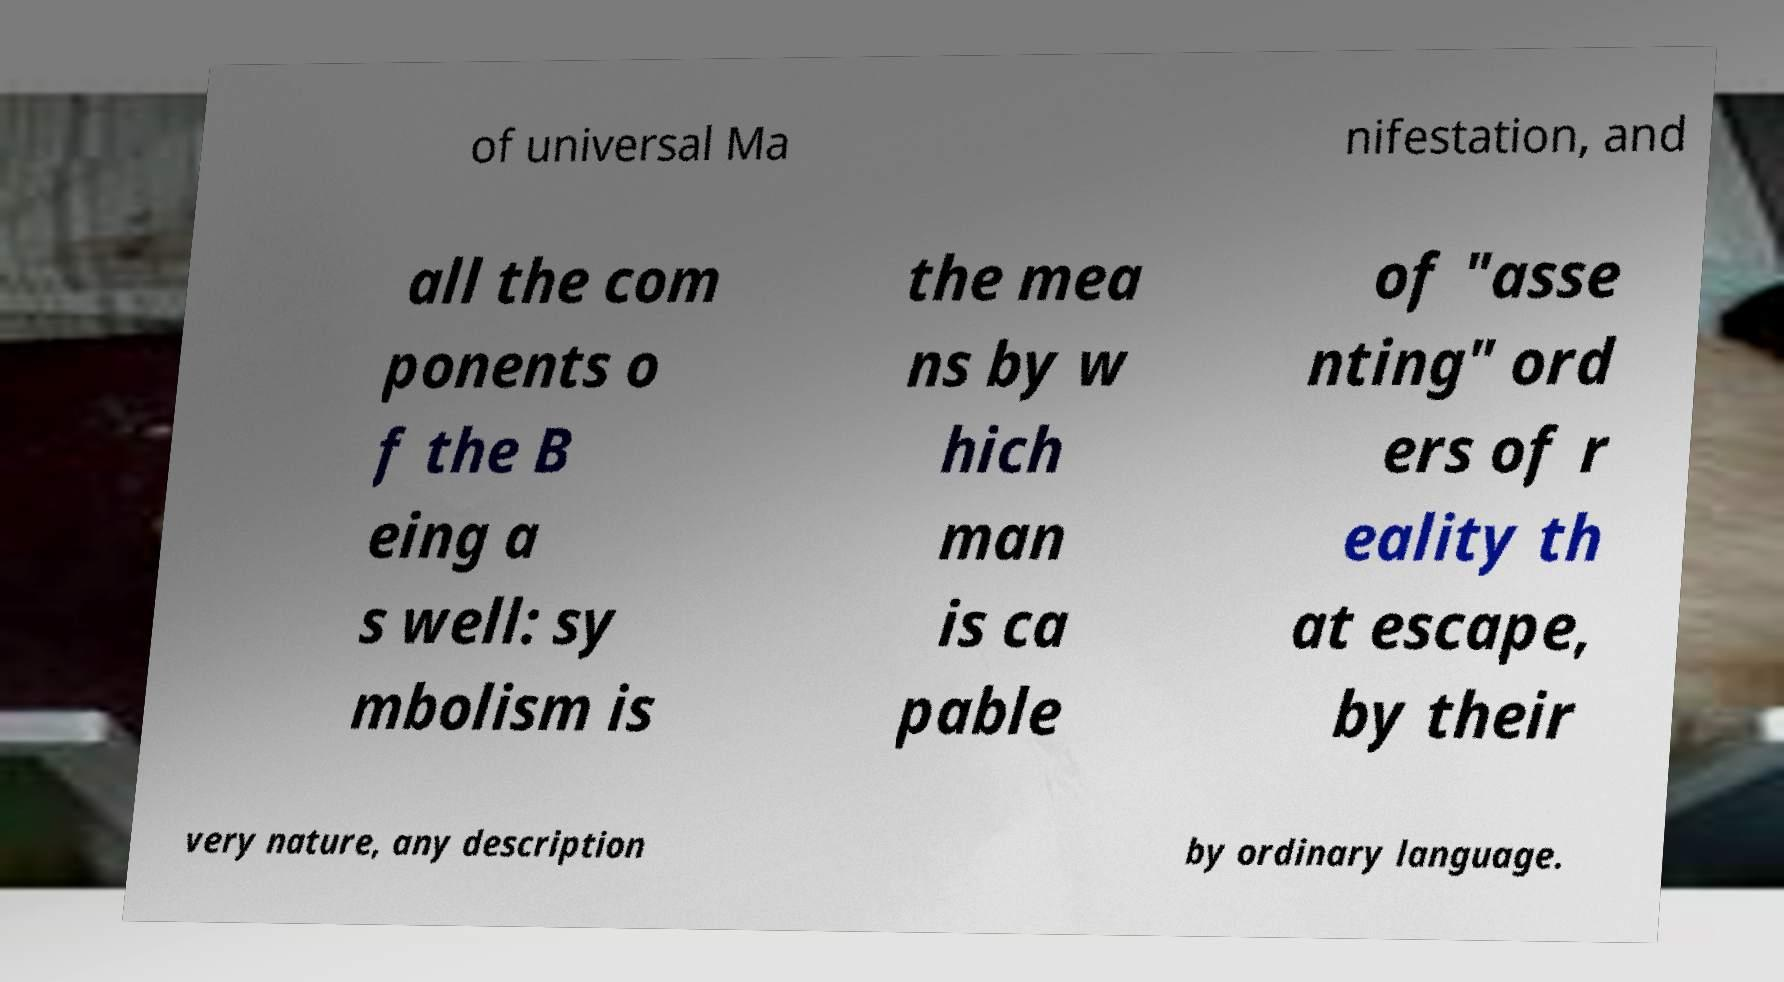There's text embedded in this image that I need extracted. Can you transcribe it verbatim? of universal Ma nifestation, and all the com ponents o f the B eing a s well: sy mbolism is the mea ns by w hich man is ca pable of "asse nting" ord ers of r eality th at escape, by their very nature, any description by ordinary language. 